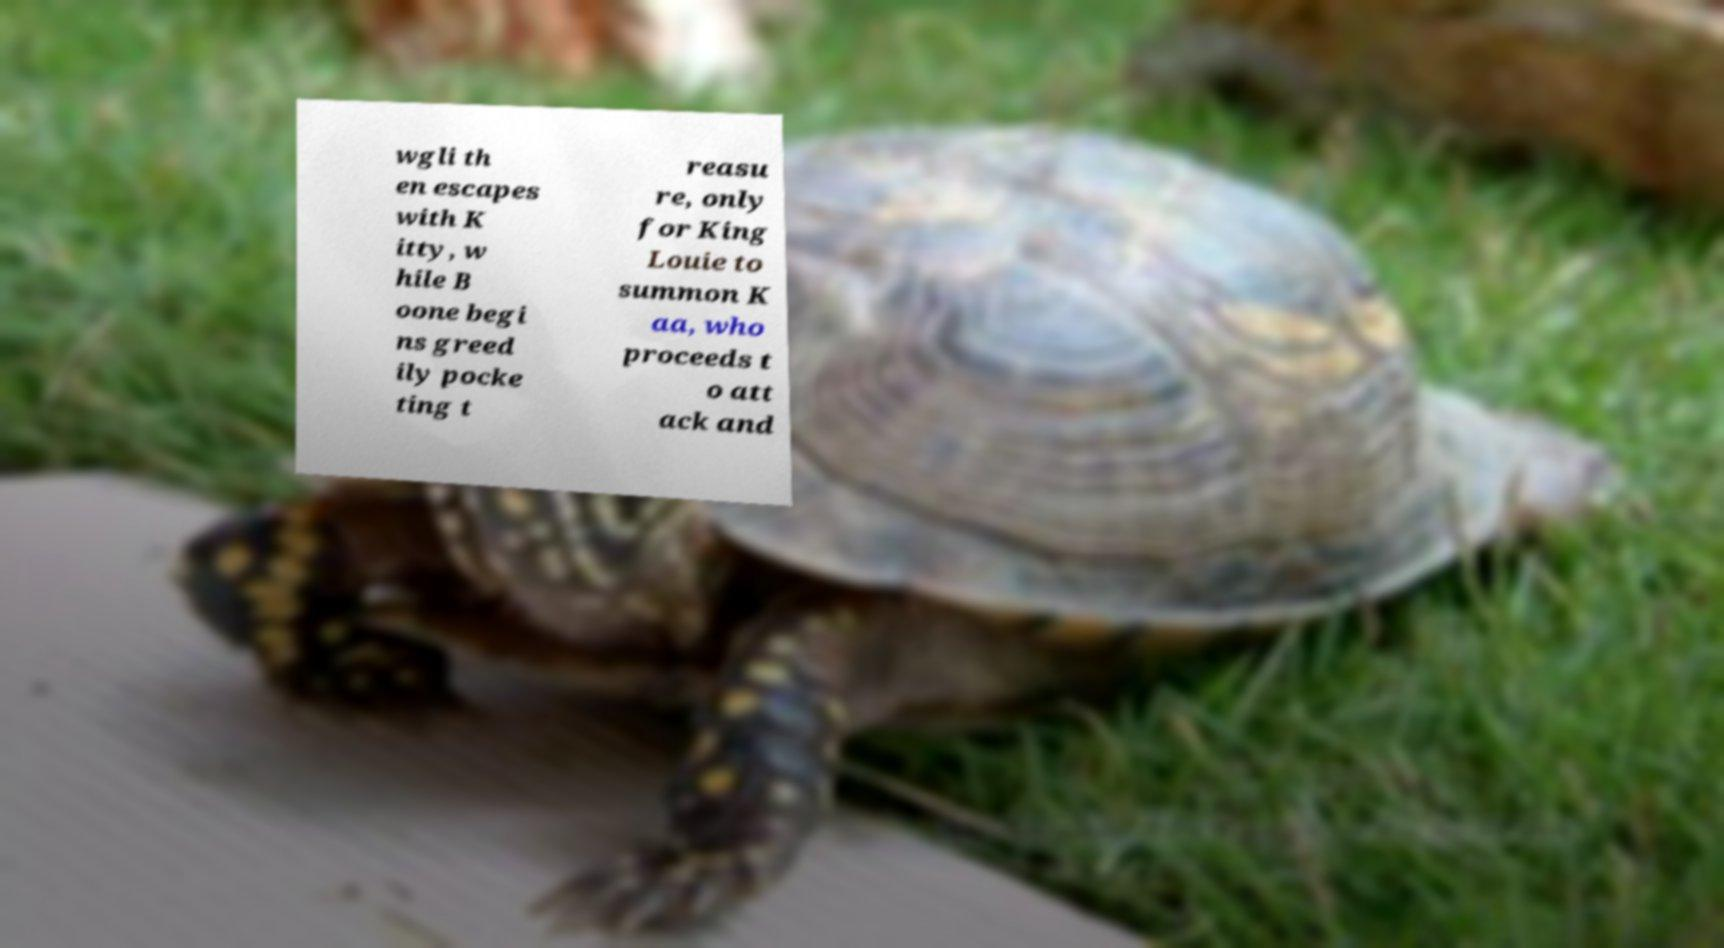Could you extract and type out the text from this image? wgli th en escapes with K itty, w hile B oone begi ns greed ily pocke ting t reasu re, only for King Louie to summon K aa, who proceeds t o att ack and 